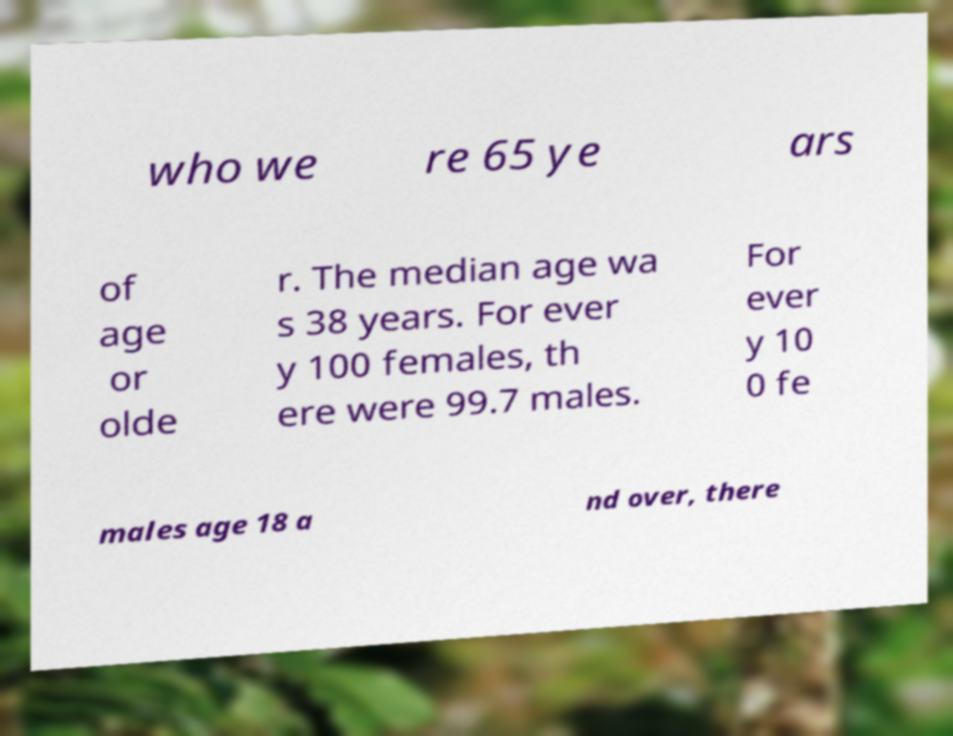Can you read and provide the text displayed in the image?This photo seems to have some interesting text. Can you extract and type it out for me? who we re 65 ye ars of age or olde r. The median age wa s 38 years. For ever y 100 females, th ere were 99.7 males. For ever y 10 0 fe males age 18 a nd over, there 